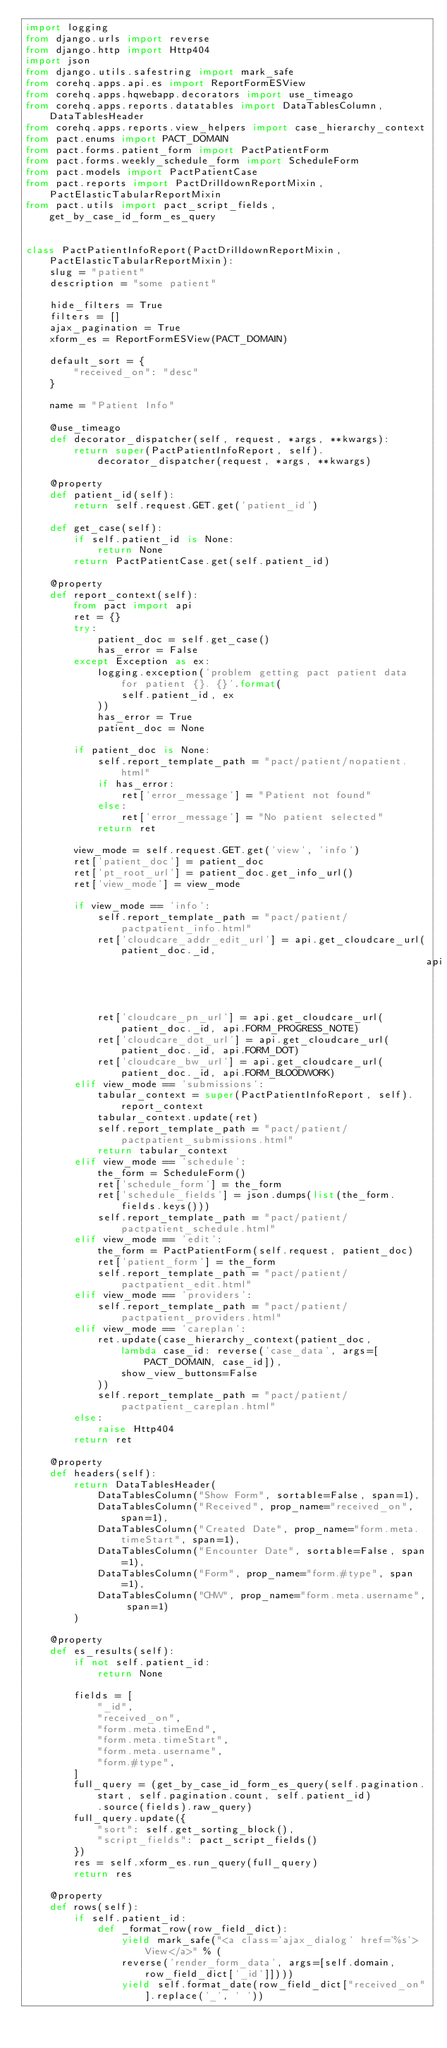<code> <loc_0><loc_0><loc_500><loc_500><_Python_>import logging
from django.urls import reverse
from django.http import Http404
import json
from django.utils.safestring import mark_safe
from corehq.apps.api.es import ReportFormESView
from corehq.apps.hqwebapp.decorators import use_timeago
from corehq.apps.reports.datatables import DataTablesColumn, DataTablesHeader
from corehq.apps.reports.view_helpers import case_hierarchy_context
from pact.enums import PACT_DOMAIN
from pact.forms.patient_form import PactPatientForm
from pact.forms.weekly_schedule_form import ScheduleForm
from pact.models import PactPatientCase
from pact.reports import PactDrilldownReportMixin, PactElasticTabularReportMixin
from pact.utils import pact_script_fields, get_by_case_id_form_es_query


class PactPatientInfoReport(PactDrilldownReportMixin, PactElasticTabularReportMixin):
    slug = "patient"
    description = "some patient"

    hide_filters = True
    filters = []
    ajax_pagination = True
    xform_es = ReportFormESView(PACT_DOMAIN)

    default_sort = {
        "received_on": "desc"
    }

    name = "Patient Info"

    @use_timeago
    def decorator_dispatcher(self, request, *args, **kwargs):
        return super(PactPatientInfoReport, self).decorator_dispatcher(request, *args, **kwargs)

    @property
    def patient_id(self):
        return self.request.GET.get('patient_id')

    def get_case(self):
        if self.patient_id is None:
            return None
        return PactPatientCase.get(self.patient_id)

    @property
    def report_context(self):
        from pact import api
        ret = {}
        try:
            patient_doc = self.get_case()
            has_error = False
        except Exception as ex:
            logging.exception('problem getting pact patient data for patient {}. {}'.format(
                self.patient_id, ex
            ))
            has_error = True
            patient_doc = None

        if patient_doc is None:
            self.report_template_path = "pact/patient/nopatient.html"
            if has_error:
                ret['error_message'] = "Patient not found"
            else:
                ret['error_message'] = "No patient selected"
            return ret

        view_mode = self.request.GET.get('view', 'info')
        ret['patient_doc'] = patient_doc
        ret['pt_root_url'] = patient_doc.get_info_url()
        ret['view_mode'] = view_mode

        if view_mode == 'info':
            self.report_template_path = "pact/patient/pactpatient_info.html"
            ret['cloudcare_addr_edit_url'] = api.get_cloudcare_url(patient_doc._id,
                                                                   api.FORM_ADDRESS)
            ret['cloudcare_pn_url'] = api.get_cloudcare_url(patient_doc._id, api.FORM_PROGRESS_NOTE)
            ret['cloudcare_dot_url'] = api.get_cloudcare_url(patient_doc._id, api.FORM_DOT)
            ret['cloudcare_bw_url'] = api.get_cloudcare_url(patient_doc._id, api.FORM_BLOODWORK)
        elif view_mode == 'submissions':
            tabular_context = super(PactPatientInfoReport, self).report_context
            tabular_context.update(ret)
            self.report_template_path = "pact/patient/pactpatient_submissions.html"
            return tabular_context
        elif view_mode == 'schedule':
            the_form = ScheduleForm()
            ret['schedule_form'] = the_form
            ret['schedule_fields'] = json.dumps(list(the_form.fields.keys()))
            self.report_template_path = "pact/patient/pactpatient_schedule.html"
        elif view_mode == 'edit':
            the_form = PactPatientForm(self.request, patient_doc)
            ret['patient_form'] = the_form
            self.report_template_path = "pact/patient/pactpatient_edit.html"
        elif view_mode == 'providers':
            self.report_template_path = "pact/patient/pactpatient_providers.html"
        elif view_mode == 'careplan':
            ret.update(case_hierarchy_context(patient_doc,
                lambda case_id: reverse('case_data', args=[PACT_DOMAIN, case_id]),
                show_view_buttons=False
            ))
            self.report_template_path = "pact/patient/pactpatient_careplan.html"
        else:
            raise Http404
        return ret

    @property
    def headers(self):
        return DataTablesHeader(
            DataTablesColumn("Show Form", sortable=False, span=1),
            DataTablesColumn("Received", prop_name="received_on", span=1),
            DataTablesColumn("Created Date", prop_name="form.meta.timeStart", span=1),
            DataTablesColumn("Encounter Date", sortable=False, span=1),
            DataTablesColumn("Form", prop_name="form.#type", span=1),
            DataTablesColumn("CHW", prop_name="form.meta.username", span=1)
        )

    @property
    def es_results(self):
        if not self.patient_id:
            return None

        fields = [
            "_id",
            "received_on",
            "form.meta.timeEnd",
            "form.meta.timeStart",
            "form.meta.username",
            "form.#type",
        ]
        full_query = (get_by_case_id_form_es_query(self.pagination.start, self.pagination.count, self.patient_id)
            .source(fields).raw_query)
        full_query.update({
            "sort": self.get_sorting_block(),
            "script_fields": pact_script_fields()
        })
        res = self.xform_es.run_query(full_query)
        return res

    @property
    def rows(self):
        if self.patient_id:
            def _format_row(row_field_dict):
                yield mark_safe("<a class='ajax_dialog' href='%s'>View</a>" % (
                reverse('render_form_data', args=[self.domain, row_field_dict['_id']])))
                yield self.format_date(row_field_dict["received_on"].replace('_', ' '))</code> 